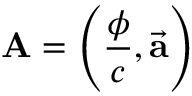Convert formula to latex. <formula><loc_0><loc_0><loc_500><loc_500>A = \left ( { \frac { \phi } { c } } , { \vec { a } } \right )</formula> 